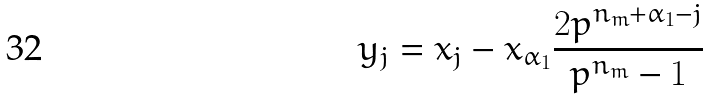Convert formula to latex. <formula><loc_0><loc_0><loc_500><loc_500>y _ { j } = x _ { j } - x _ { \alpha _ { 1 } } \frac { 2 p ^ { n _ { m } + \alpha _ { 1 } - j } } { p ^ { n _ { m } } - 1 }</formula> 